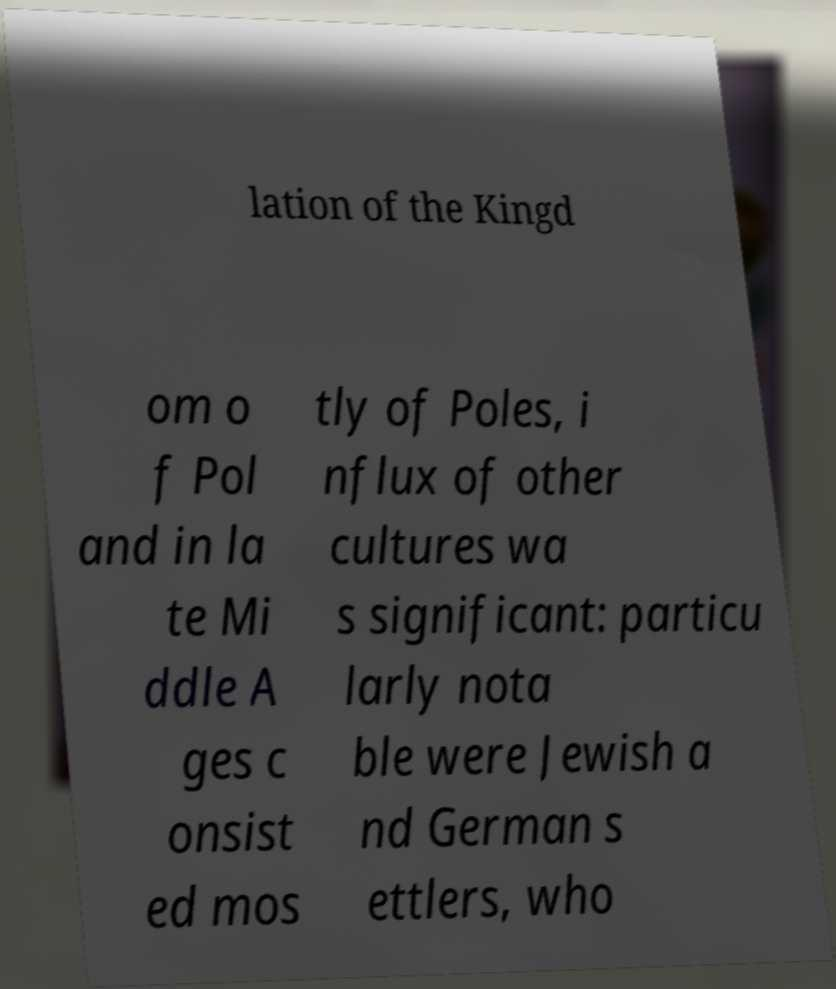For documentation purposes, I need the text within this image transcribed. Could you provide that? lation of the Kingd om o f Pol and in la te Mi ddle A ges c onsist ed mos tly of Poles, i nflux of other cultures wa s significant: particu larly nota ble were Jewish a nd German s ettlers, who 